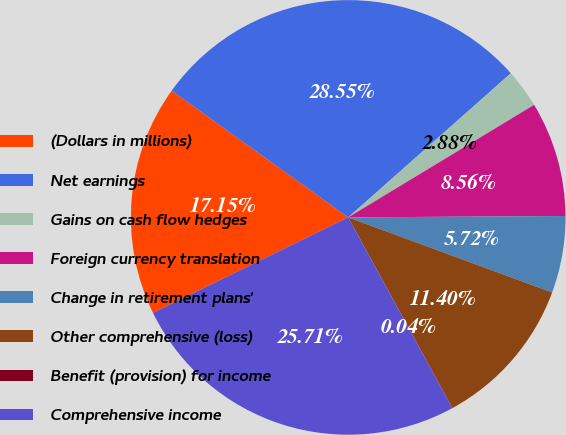Convert chart. <chart><loc_0><loc_0><loc_500><loc_500><pie_chart><fcel>(Dollars in millions)<fcel>Net earnings<fcel>Gains on cash flow hedges<fcel>Foreign currency translation<fcel>Change in retirement plans'<fcel>Other comprehensive (loss)<fcel>Benefit (provision) for income<fcel>Comprehensive income<nl><fcel>17.15%<fcel>28.55%<fcel>2.88%<fcel>8.56%<fcel>5.72%<fcel>11.4%<fcel>0.04%<fcel>25.71%<nl></chart> 